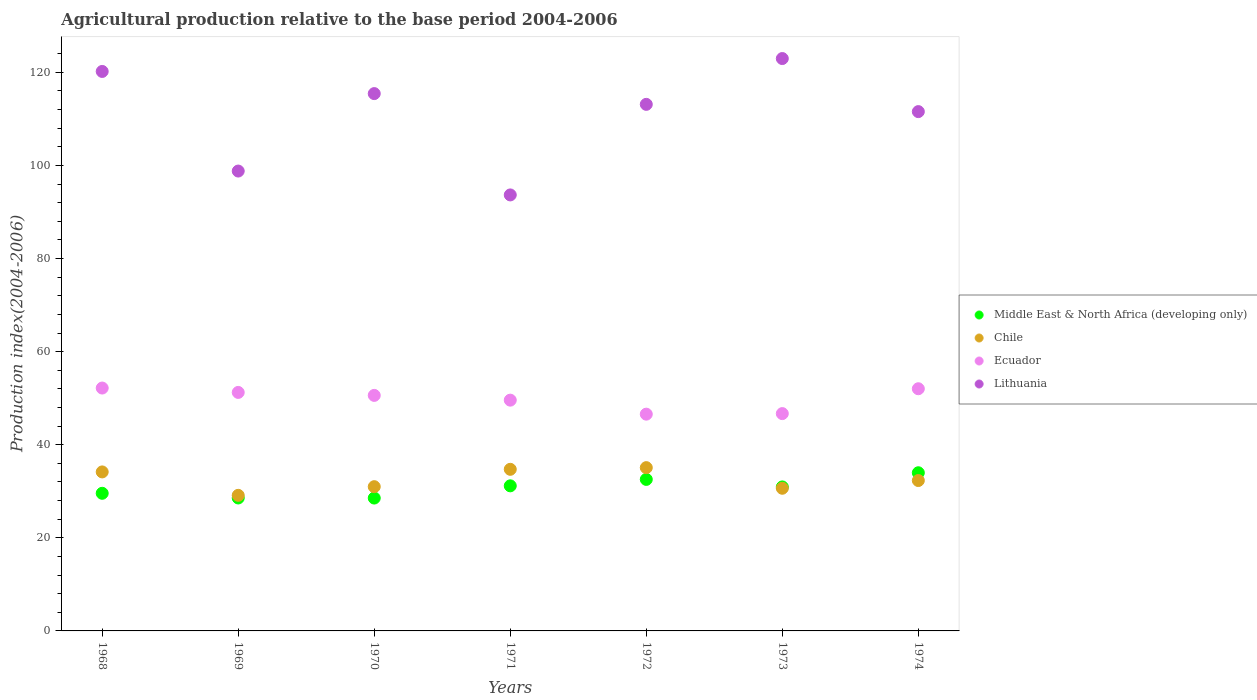Is the number of dotlines equal to the number of legend labels?
Provide a short and direct response. Yes. What is the agricultural production index in Lithuania in 1971?
Make the answer very short. 93.67. Across all years, what is the maximum agricultural production index in Middle East & North Africa (developing only)?
Ensure brevity in your answer.  33.98. Across all years, what is the minimum agricultural production index in Middle East & North Africa (developing only)?
Your answer should be very brief. 28.54. In which year was the agricultural production index in Lithuania maximum?
Make the answer very short. 1973. What is the total agricultural production index in Chile in the graph?
Offer a very short reply. 227.04. What is the difference between the agricultural production index in Lithuania in 1970 and that in 1971?
Give a very brief answer. 21.77. What is the difference between the agricultural production index in Middle East & North Africa (developing only) in 1972 and the agricultural production index in Ecuador in 1970?
Provide a succinct answer. -18.05. What is the average agricultural production index in Middle East & North Africa (developing only) per year?
Your response must be concise. 30.76. In the year 1973, what is the difference between the agricultural production index in Chile and agricultural production index in Middle East & North Africa (developing only)?
Keep it short and to the point. -0.29. In how many years, is the agricultural production index in Ecuador greater than 48?
Make the answer very short. 5. What is the ratio of the agricultural production index in Ecuador in 1972 to that in 1973?
Ensure brevity in your answer.  1. Is the difference between the agricultural production index in Chile in 1968 and 1974 greater than the difference between the agricultural production index in Middle East & North Africa (developing only) in 1968 and 1974?
Offer a terse response. Yes. What is the difference between the highest and the second highest agricultural production index in Chile?
Your response must be concise. 0.36. What is the difference between the highest and the lowest agricultural production index in Ecuador?
Make the answer very short. 5.61. In how many years, is the agricultural production index in Ecuador greater than the average agricultural production index in Ecuador taken over all years?
Make the answer very short. 4. Is the sum of the agricultural production index in Lithuania in 1968 and 1974 greater than the maximum agricultural production index in Chile across all years?
Offer a very short reply. Yes. Is the agricultural production index in Middle East & North Africa (developing only) strictly greater than the agricultural production index in Ecuador over the years?
Keep it short and to the point. No. How many dotlines are there?
Provide a succinct answer. 4. How many years are there in the graph?
Your answer should be very brief. 7. What is the difference between two consecutive major ticks on the Y-axis?
Give a very brief answer. 20. Does the graph contain any zero values?
Give a very brief answer. No. Does the graph contain grids?
Offer a terse response. No. How many legend labels are there?
Provide a short and direct response. 4. What is the title of the graph?
Provide a short and direct response. Agricultural production relative to the base period 2004-2006. What is the label or title of the Y-axis?
Your response must be concise. Production index(2004-2006). What is the Production index(2004-2006) of Middle East & North Africa (developing only) in 1968?
Keep it short and to the point. 29.57. What is the Production index(2004-2006) of Chile in 1968?
Your answer should be compact. 34.16. What is the Production index(2004-2006) of Ecuador in 1968?
Your answer should be compact. 52.18. What is the Production index(2004-2006) of Lithuania in 1968?
Your answer should be compact. 120.2. What is the Production index(2004-2006) in Middle East & North Africa (developing only) in 1969?
Your response must be concise. 28.56. What is the Production index(2004-2006) of Chile in 1969?
Keep it short and to the point. 29.13. What is the Production index(2004-2006) in Ecuador in 1969?
Provide a succinct answer. 51.24. What is the Production index(2004-2006) of Lithuania in 1969?
Provide a short and direct response. 98.8. What is the Production index(2004-2006) of Middle East & North Africa (developing only) in 1970?
Your answer should be compact. 28.54. What is the Production index(2004-2006) of Chile in 1970?
Make the answer very short. 30.99. What is the Production index(2004-2006) in Ecuador in 1970?
Provide a succinct answer. 50.6. What is the Production index(2004-2006) of Lithuania in 1970?
Keep it short and to the point. 115.44. What is the Production index(2004-2006) of Middle East & North Africa (developing only) in 1971?
Make the answer very short. 31.17. What is the Production index(2004-2006) of Chile in 1971?
Ensure brevity in your answer.  34.72. What is the Production index(2004-2006) of Ecuador in 1971?
Keep it short and to the point. 49.58. What is the Production index(2004-2006) in Lithuania in 1971?
Ensure brevity in your answer.  93.67. What is the Production index(2004-2006) of Middle East & North Africa (developing only) in 1972?
Offer a terse response. 32.55. What is the Production index(2004-2006) of Chile in 1972?
Offer a terse response. 35.08. What is the Production index(2004-2006) of Ecuador in 1972?
Provide a succinct answer. 46.57. What is the Production index(2004-2006) in Lithuania in 1972?
Provide a succinct answer. 113.13. What is the Production index(2004-2006) of Middle East & North Africa (developing only) in 1973?
Ensure brevity in your answer.  30.94. What is the Production index(2004-2006) of Chile in 1973?
Offer a terse response. 30.65. What is the Production index(2004-2006) of Ecuador in 1973?
Your answer should be compact. 46.69. What is the Production index(2004-2006) of Lithuania in 1973?
Your answer should be compact. 122.97. What is the Production index(2004-2006) of Middle East & North Africa (developing only) in 1974?
Offer a very short reply. 33.98. What is the Production index(2004-2006) in Chile in 1974?
Offer a very short reply. 32.31. What is the Production index(2004-2006) in Ecuador in 1974?
Make the answer very short. 52.03. What is the Production index(2004-2006) of Lithuania in 1974?
Offer a very short reply. 111.57. Across all years, what is the maximum Production index(2004-2006) of Middle East & North Africa (developing only)?
Your response must be concise. 33.98. Across all years, what is the maximum Production index(2004-2006) of Chile?
Keep it short and to the point. 35.08. Across all years, what is the maximum Production index(2004-2006) of Ecuador?
Your answer should be very brief. 52.18. Across all years, what is the maximum Production index(2004-2006) of Lithuania?
Make the answer very short. 122.97. Across all years, what is the minimum Production index(2004-2006) in Middle East & North Africa (developing only)?
Provide a succinct answer. 28.54. Across all years, what is the minimum Production index(2004-2006) in Chile?
Your answer should be compact. 29.13. Across all years, what is the minimum Production index(2004-2006) of Ecuador?
Your answer should be very brief. 46.57. Across all years, what is the minimum Production index(2004-2006) of Lithuania?
Your answer should be compact. 93.67. What is the total Production index(2004-2006) of Middle East & North Africa (developing only) in the graph?
Your answer should be very brief. 215.31. What is the total Production index(2004-2006) in Chile in the graph?
Your answer should be compact. 227.04. What is the total Production index(2004-2006) in Ecuador in the graph?
Offer a very short reply. 348.89. What is the total Production index(2004-2006) of Lithuania in the graph?
Provide a short and direct response. 775.78. What is the difference between the Production index(2004-2006) of Middle East & North Africa (developing only) in 1968 and that in 1969?
Offer a very short reply. 1.01. What is the difference between the Production index(2004-2006) in Chile in 1968 and that in 1969?
Provide a short and direct response. 5.03. What is the difference between the Production index(2004-2006) of Lithuania in 1968 and that in 1969?
Your answer should be compact. 21.4. What is the difference between the Production index(2004-2006) of Middle East & North Africa (developing only) in 1968 and that in 1970?
Ensure brevity in your answer.  1.02. What is the difference between the Production index(2004-2006) in Chile in 1968 and that in 1970?
Keep it short and to the point. 3.17. What is the difference between the Production index(2004-2006) of Ecuador in 1968 and that in 1970?
Provide a short and direct response. 1.58. What is the difference between the Production index(2004-2006) in Lithuania in 1968 and that in 1970?
Your answer should be very brief. 4.76. What is the difference between the Production index(2004-2006) of Middle East & North Africa (developing only) in 1968 and that in 1971?
Give a very brief answer. -1.6. What is the difference between the Production index(2004-2006) of Chile in 1968 and that in 1971?
Provide a short and direct response. -0.56. What is the difference between the Production index(2004-2006) of Ecuador in 1968 and that in 1971?
Ensure brevity in your answer.  2.6. What is the difference between the Production index(2004-2006) in Lithuania in 1968 and that in 1971?
Ensure brevity in your answer.  26.53. What is the difference between the Production index(2004-2006) in Middle East & North Africa (developing only) in 1968 and that in 1972?
Offer a terse response. -2.98. What is the difference between the Production index(2004-2006) of Chile in 1968 and that in 1972?
Your answer should be compact. -0.92. What is the difference between the Production index(2004-2006) of Ecuador in 1968 and that in 1972?
Make the answer very short. 5.61. What is the difference between the Production index(2004-2006) of Lithuania in 1968 and that in 1972?
Offer a terse response. 7.07. What is the difference between the Production index(2004-2006) in Middle East & North Africa (developing only) in 1968 and that in 1973?
Your response must be concise. -1.37. What is the difference between the Production index(2004-2006) in Chile in 1968 and that in 1973?
Ensure brevity in your answer.  3.51. What is the difference between the Production index(2004-2006) of Ecuador in 1968 and that in 1973?
Make the answer very short. 5.49. What is the difference between the Production index(2004-2006) of Lithuania in 1968 and that in 1973?
Offer a very short reply. -2.77. What is the difference between the Production index(2004-2006) in Middle East & North Africa (developing only) in 1968 and that in 1974?
Ensure brevity in your answer.  -4.41. What is the difference between the Production index(2004-2006) in Chile in 1968 and that in 1974?
Offer a very short reply. 1.85. What is the difference between the Production index(2004-2006) of Ecuador in 1968 and that in 1974?
Your answer should be compact. 0.15. What is the difference between the Production index(2004-2006) of Lithuania in 1968 and that in 1974?
Offer a very short reply. 8.63. What is the difference between the Production index(2004-2006) of Middle East & North Africa (developing only) in 1969 and that in 1970?
Keep it short and to the point. 0.02. What is the difference between the Production index(2004-2006) in Chile in 1969 and that in 1970?
Offer a very short reply. -1.86. What is the difference between the Production index(2004-2006) in Ecuador in 1969 and that in 1970?
Make the answer very short. 0.64. What is the difference between the Production index(2004-2006) in Lithuania in 1969 and that in 1970?
Your answer should be compact. -16.64. What is the difference between the Production index(2004-2006) of Middle East & North Africa (developing only) in 1969 and that in 1971?
Your answer should be compact. -2.61. What is the difference between the Production index(2004-2006) of Chile in 1969 and that in 1971?
Your response must be concise. -5.59. What is the difference between the Production index(2004-2006) in Ecuador in 1969 and that in 1971?
Your answer should be compact. 1.66. What is the difference between the Production index(2004-2006) in Lithuania in 1969 and that in 1971?
Offer a terse response. 5.13. What is the difference between the Production index(2004-2006) of Middle East & North Africa (developing only) in 1969 and that in 1972?
Ensure brevity in your answer.  -3.99. What is the difference between the Production index(2004-2006) in Chile in 1969 and that in 1972?
Give a very brief answer. -5.95. What is the difference between the Production index(2004-2006) in Ecuador in 1969 and that in 1972?
Your answer should be compact. 4.67. What is the difference between the Production index(2004-2006) in Lithuania in 1969 and that in 1972?
Provide a short and direct response. -14.33. What is the difference between the Production index(2004-2006) in Middle East & North Africa (developing only) in 1969 and that in 1973?
Offer a terse response. -2.38. What is the difference between the Production index(2004-2006) of Chile in 1969 and that in 1973?
Offer a very short reply. -1.52. What is the difference between the Production index(2004-2006) of Ecuador in 1969 and that in 1973?
Your response must be concise. 4.55. What is the difference between the Production index(2004-2006) in Lithuania in 1969 and that in 1973?
Keep it short and to the point. -24.17. What is the difference between the Production index(2004-2006) in Middle East & North Africa (developing only) in 1969 and that in 1974?
Provide a short and direct response. -5.42. What is the difference between the Production index(2004-2006) of Chile in 1969 and that in 1974?
Make the answer very short. -3.18. What is the difference between the Production index(2004-2006) in Ecuador in 1969 and that in 1974?
Your answer should be very brief. -0.79. What is the difference between the Production index(2004-2006) of Lithuania in 1969 and that in 1974?
Your answer should be very brief. -12.77. What is the difference between the Production index(2004-2006) in Middle East & North Africa (developing only) in 1970 and that in 1971?
Give a very brief answer. -2.63. What is the difference between the Production index(2004-2006) in Chile in 1970 and that in 1971?
Ensure brevity in your answer.  -3.73. What is the difference between the Production index(2004-2006) in Lithuania in 1970 and that in 1971?
Provide a succinct answer. 21.77. What is the difference between the Production index(2004-2006) of Middle East & North Africa (developing only) in 1970 and that in 1972?
Offer a terse response. -4.01. What is the difference between the Production index(2004-2006) of Chile in 1970 and that in 1972?
Your response must be concise. -4.09. What is the difference between the Production index(2004-2006) of Ecuador in 1970 and that in 1972?
Keep it short and to the point. 4.03. What is the difference between the Production index(2004-2006) of Lithuania in 1970 and that in 1972?
Your response must be concise. 2.31. What is the difference between the Production index(2004-2006) in Middle East & North Africa (developing only) in 1970 and that in 1973?
Ensure brevity in your answer.  -2.39. What is the difference between the Production index(2004-2006) in Chile in 1970 and that in 1973?
Provide a short and direct response. 0.34. What is the difference between the Production index(2004-2006) in Ecuador in 1970 and that in 1973?
Offer a terse response. 3.91. What is the difference between the Production index(2004-2006) of Lithuania in 1970 and that in 1973?
Offer a terse response. -7.53. What is the difference between the Production index(2004-2006) of Middle East & North Africa (developing only) in 1970 and that in 1974?
Keep it short and to the point. -5.44. What is the difference between the Production index(2004-2006) of Chile in 1970 and that in 1974?
Offer a very short reply. -1.32. What is the difference between the Production index(2004-2006) in Ecuador in 1970 and that in 1974?
Offer a terse response. -1.43. What is the difference between the Production index(2004-2006) in Lithuania in 1970 and that in 1974?
Keep it short and to the point. 3.87. What is the difference between the Production index(2004-2006) in Middle East & North Africa (developing only) in 1971 and that in 1972?
Provide a short and direct response. -1.38. What is the difference between the Production index(2004-2006) of Chile in 1971 and that in 1972?
Ensure brevity in your answer.  -0.36. What is the difference between the Production index(2004-2006) in Ecuador in 1971 and that in 1972?
Your response must be concise. 3.01. What is the difference between the Production index(2004-2006) of Lithuania in 1971 and that in 1972?
Provide a succinct answer. -19.46. What is the difference between the Production index(2004-2006) in Middle East & North Africa (developing only) in 1971 and that in 1973?
Your response must be concise. 0.24. What is the difference between the Production index(2004-2006) in Chile in 1971 and that in 1973?
Ensure brevity in your answer.  4.07. What is the difference between the Production index(2004-2006) of Ecuador in 1971 and that in 1973?
Keep it short and to the point. 2.89. What is the difference between the Production index(2004-2006) in Lithuania in 1971 and that in 1973?
Give a very brief answer. -29.3. What is the difference between the Production index(2004-2006) of Middle East & North Africa (developing only) in 1971 and that in 1974?
Keep it short and to the point. -2.81. What is the difference between the Production index(2004-2006) in Chile in 1971 and that in 1974?
Give a very brief answer. 2.41. What is the difference between the Production index(2004-2006) of Ecuador in 1971 and that in 1974?
Ensure brevity in your answer.  -2.45. What is the difference between the Production index(2004-2006) of Lithuania in 1971 and that in 1974?
Give a very brief answer. -17.9. What is the difference between the Production index(2004-2006) in Middle East & North Africa (developing only) in 1972 and that in 1973?
Offer a terse response. 1.62. What is the difference between the Production index(2004-2006) in Chile in 1972 and that in 1973?
Make the answer very short. 4.43. What is the difference between the Production index(2004-2006) of Ecuador in 1972 and that in 1973?
Your answer should be compact. -0.12. What is the difference between the Production index(2004-2006) of Lithuania in 1972 and that in 1973?
Give a very brief answer. -9.84. What is the difference between the Production index(2004-2006) of Middle East & North Africa (developing only) in 1972 and that in 1974?
Your answer should be very brief. -1.43. What is the difference between the Production index(2004-2006) of Chile in 1972 and that in 1974?
Your answer should be very brief. 2.77. What is the difference between the Production index(2004-2006) in Ecuador in 1972 and that in 1974?
Provide a succinct answer. -5.46. What is the difference between the Production index(2004-2006) in Lithuania in 1972 and that in 1974?
Make the answer very short. 1.56. What is the difference between the Production index(2004-2006) in Middle East & North Africa (developing only) in 1973 and that in 1974?
Provide a short and direct response. -3.04. What is the difference between the Production index(2004-2006) of Chile in 1973 and that in 1974?
Offer a terse response. -1.66. What is the difference between the Production index(2004-2006) of Ecuador in 1973 and that in 1974?
Give a very brief answer. -5.34. What is the difference between the Production index(2004-2006) in Lithuania in 1973 and that in 1974?
Ensure brevity in your answer.  11.4. What is the difference between the Production index(2004-2006) in Middle East & North Africa (developing only) in 1968 and the Production index(2004-2006) in Chile in 1969?
Your answer should be very brief. 0.44. What is the difference between the Production index(2004-2006) in Middle East & North Africa (developing only) in 1968 and the Production index(2004-2006) in Ecuador in 1969?
Ensure brevity in your answer.  -21.67. What is the difference between the Production index(2004-2006) of Middle East & North Africa (developing only) in 1968 and the Production index(2004-2006) of Lithuania in 1969?
Ensure brevity in your answer.  -69.23. What is the difference between the Production index(2004-2006) in Chile in 1968 and the Production index(2004-2006) in Ecuador in 1969?
Your answer should be very brief. -17.08. What is the difference between the Production index(2004-2006) in Chile in 1968 and the Production index(2004-2006) in Lithuania in 1969?
Your answer should be compact. -64.64. What is the difference between the Production index(2004-2006) of Ecuador in 1968 and the Production index(2004-2006) of Lithuania in 1969?
Offer a very short reply. -46.62. What is the difference between the Production index(2004-2006) in Middle East & North Africa (developing only) in 1968 and the Production index(2004-2006) in Chile in 1970?
Make the answer very short. -1.42. What is the difference between the Production index(2004-2006) in Middle East & North Africa (developing only) in 1968 and the Production index(2004-2006) in Ecuador in 1970?
Your answer should be very brief. -21.03. What is the difference between the Production index(2004-2006) of Middle East & North Africa (developing only) in 1968 and the Production index(2004-2006) of Lithuania in 1970?
Your answer should be very brief. -85.87. What is the difference between the Production index(2004-2006) of Chile in 1968 and the Production index(2004-2006) of Ecuador in 1970?
Ensure brevity in your answer.  -16.44. What is the difference between the Production index(2004-2006) of Chile in 1968 and the Production index(2004-2006) of Lithuania in 1970?
Provide a short and direct response. -81.28. What is the difference between the Production index(2004-2006) in Ecuador in 1968 and the Production index(2004-2006) in Lithuania in 1970?
Keep it short and to the point. -63.26. What is the difference between the Production index(2004-2006) of Middle East & North Africa (developing only) in 1968 and the Production index(2004-2006) of Chile in 1971?
Ensure brevity in your answer.  -5.15. What is the difference between the Production index(2004-2006) of Middle East & North Africa (developing only) in 1968 and the Production index(2004-2006) of Ecuador in 1971?
Your answer should be compact. -20.01. What is the difference between the Production index(2004-2006) of Middle East & North Africa (developing only) in 1968 and the Production index(2004-2006) of Lithuania in 1971?
Provide a short and direct response. -64.1. What is the difference between the Production index(2004-2006) in Chile in 1968 and the Production index(2004-2006) in Ecuador in 1971?
Provide a succinct answer. -15.42. What is the difference between the Production index(2004-2006) of Chile in 1968 and the Production index(2004-2006) of Lithuania in 1971?
Your answer should be compact. -59.51. What is the difference between the Production index(2004-2006) of Ecuador in 1968 and the Production index(2004-2006) of Lithuania in 1971?
Offer a terse response. -41.49. What is the difference between the Production index(2004-2006) in Middle East & North Africa (developing only) in 1968 and the Production index(2004-2006) in Chile in 1972?
Ensure brevity in your answer.  -5.51. What is the difference between the Production index(2004-2006) in Middle East & North Africa (developing only) in 1968 and the Production index(2004-2006) in Ecuador in 1972?
Keep it short and to the point. -17. What is the difference between the Production index(2004-2006) in Middle East & North Africa (developing only) in 1968 and the Production index(2004-2006) in Lithuania in 1972?
Give a very brief answer. -83.56. What is the difference between the Production index(2004-2006) in Chile in 1968 and the Production index(2004-2006) in Ecuador in 1972?
Offer a very short reply. -12.41. What is the difference between the Production index(2004-2006) of Chile in 1968 and the Production index(2004-2006) of Lithuania in 1972?
Ensure brevity in your answer.  -78.97. What is the difference between the Production index(2004-2006) of Ecuador in 1968 and the Production index(2004-2006) of Lithuania in 1972?
Offer a very short reply. -60.95. What is the difference between the Production index(2004-2006) in Middle East & North Africa (developing only) in 1968 and the Production index(2004-2006) in Chile in 1973?
Provide a succinct answer. -1.08. What is the difference between the Production index(2004-2006) in Middle East & North Africa (developing only) in 1968 and the Production index(2004-2006) in Ecuador in 1973?
Offer a terse response. -17.12. What is the difference between the Production index(2004-2006) of Middle East & North Africa (developing only) in 1968 and the Production index(2004-2006) of Lithuania in 1973?
Ensure brevity in your answer.  -93.4. What is the difference between the Production index(2004-2006) in Chile in 1968 and the Production index(2004-2006) in Ecuador in 1973?
Provide a short and direct response. -12.53. What is the difference between the Production index(2004-2006) of Chile in 1968 and the Production index(2004-2006) of Lithuania in 1973?
Provide a short and direct response. -88.81. What is the difference between the Production index(2004-2006) in Ecuador in 1968 and the Production index(2004-2006) in Lithuania in 1973?
Your response must be concise. -70.79. What is the difference between the Production index(2004-2006) in Middle East & North Africa (developing only) in 1968 and the Production index(2004-2006) in Chile in 1974?
Provide a succinct answer. -2.74. What is the difference between the Production index(2004-2006) of Middle East & North Africa (developing only) in 1968 and the Production index(2004-2006) of Ecuador in 1974?
Ensure brevity in your answer.  -22.46. What is the difference between the Production index(2004-2006) in Middle East & North Africa (developing only) in 1968 and the Production index(2004-2006) in Lithuania in 1974?
Keep it short and to the point. -82. What is the difference between the Production index(2004-2006) of Chile in 1968 and the Production index(2004-2006) of Ecuador in 1974?
Keep it short and to the point. -17.87. What is the difference between the Production index(2004-2006) in Chile in 1968 and the Production index(2004-2006) in Lithuania in 1974?
Your answer should be compact. -77.41. What is the difference between the Production index(2004-2006) of Ecuador in 1968 and the Production index(2004-2006) of Lithuania in 1974?
Make the answer very short. -59.39. What is the difference between the Production index(2004-2006) in Middle East & North Africa (developing only) in 1969 and the Production index(2004-2006) in Chile in 1970?
Your answer should be very brief. -2.43. What is the difference between the Production index(2004-2006) of Middle East & North Africa (developing only) in 1969 and the Production index(2004-2006) of Ecuador in 1970?
Provide a short and direct response. -22.04. What is the difference between the Production index(2004-2006) in Middle East & North Africa (developing only) in 1969 and the Production index(2004-2006) in Lithuania in 1970?
Your answer should be very brief. -86.88. What is the difference between the Production index(2004-2006) in Chile in 1969 and the Production index(2004-2006) in Ecuador in 1970?
Your answer should be compact. -21.47. What is the difference between the Production index(2004-2006) in Chile in 1969 and the Production index(2004-2006) in Lithuania in 1970?
Your answer should be very brief. -86.31. What is the difference between the Production index(2004-2006) of Ecuador in 1969 and the Production index(2004-2006) of Lithuania in 1970?
Your response must be concise. -64.2. What is the difference between the Production index(2004-2006) of Middle East & North Africa (developing only) in 1969 and the Production index(2004-2006) of Chile in 1971?
Give a very brief answer. -6.16. What is the difference between the Production index(2004-2006) in Middle East & North Africa (developing only) in 1969 and the Production index(2004-2006) in Ecuador in 1971?
Offer a terse response. -21.02. What is the difference between the Production index(2004-2006) of Middle East & North Africa (developing only) in 1969 and the Production index(2004-2006) of Lithuania in 1971?
Your answer should be very brief. -65.11. What is the difference between the Production index(2004-2006) in Chile in 1969 and the Production index(2004-2006) in Ecuador in 1971?
Your response must be concise. -20.45. What is the difference between the Production index(2004-2006) in Chile in 1969 and the Production index(2004-2006) in Lithuania in 1971?
Provide a short and direct response. -64.54. What is the difference between the Production index(2004-2006) of Ecuador in 1969 and the Production index(2004-2006) of Lithuania in 1971?
Give a very brief answer. -42.43. What is the difference between the Production index(2004-2006) in Middle East & North Africa (developing only) in 1969 and the Production index(2004-2006) in Chile in 1972?
Your answer should be very brief. -6.52. What is the difference between the Production index(2004-2006) in Middle East & North Africa (developing only) in 1969 and the Production index(2004-2006) in Ecuador in 1972?
Provide a short and direct response. -18.01. What is the difference between the Production index(2004-2006) in Middle East & North Africa (developing only) in 1969 and the Production index(2004-2006) in Lithuania in 1972?
Give a very brief answer. -84.57. What is the difference between the Production index(2004-2006) in Chile in 1969 and the Production index(2004-2006) in Ecuador in 1972?
Your response must be concise. -17.44. What is the difference between the Production index(2004-2006) in Chile in 1969 and the Production index(2004-2006) in Lithuania in 1972?
Provide a succinct answer. -84. What is the difference between the Production index(2004-2006) in Ecuador in 1969 and the Production index(2004-2006) in Lithuania in 1972?
Provide a short and direct response. -61.89. What is the difference between the Production index(2004-2006) in Middle East & North Africa (developing only) in 1969 and the Production index(2004-2006) in Chile in 1973?
Your answer should be very brief. -2.09. What is the difference between the Production index(2004-2006) in Middle East & North Africa (developing only) in 1969 and the Production index(2004-2006) in Ecuador in 1973?
Your answer should be compact. -18.13. What is the difference between the Production index(2004-2006) of Middle East & North Africa (developing only) in 1969 and the Production index(2004-2006) of Lithuania in 1973?
Ensure brevity in your answer.  -94.41. What is the difference between the Production index(2004-2006) of Chile in 1969 and the Production index(2004-2006) of Ecuador in 1973?
Provide a short and direct response. -17.56. What is the difference between the Production index(2004-2006) in Chile in 1969 and the Production index(2004-2006) in Lithuania in 1973?
Give a very brief answer. -93.84. What is the difference between the Production index(2004-2006) in Ecuador in 1969 and the Production index(2004-2006) in Lithuania in 1973?
Make the answer very short. -71.73. What is the difference between the Production index(2004-2006) in Middle East & North Africa (developing only) in 1969 and the Production index(2004-2006) in Chile in 1974?
Provide a succinct answer. -3.75. What is the difference between the Production index(2004-2006) of Middle East & North Africa (developing only) in 1969 and the Production index(2004-2006) of Ecuador in 1974?
Your answer should be compact. -23.47. What is the difference between the Production index(2004-2006) of Middle East & North Africa (developing only) in 1969 and the Production index(2004-2006) of Lithuania in 1974?
Your answer should be compact. -83.01. What is the difference between the Production index(2004-2006) in Chile in 1969 and the Production index(2004-2006) in Ecuador in 1974?
Provide a succinct answer. -22.9. What is the difference between the Production index(2004-2006) of Chile in 1969 and the Production index(2004-2006) of Lithuania in 1974?
Offer a terse response. -82.44. What is the difference between the Production index(2004-2006) in Ecuador in 1969 and the Production index(2004-2006) in Lithuania in 1974?
Your answer should be very brief. -60.33. What is the difference between the Production index(2004-2006) of Middle East & North Africa (developing only) in 1970 and the Production index(2004-2006) of Chile in 1971?
Make the answer very short. -6.18. What is the difference between the Production index(2004-2006) in Middle East & North Africa (developing only) in 1970 and the Production index(2004-2006) in Ecuador in 1971?
Your answer should be compact. -21.04. What is the difference between the Production index(2004-2006) of Middle East & North Africa (developing only) in 1970 and the Production index(2004-2006) of Lithuania in 1971?
Your response must be concise. -65.13. What is the difference between the Production index(2004-2006) of Chile in 1970 and the Production index(2004-2006) of Ecuador in 1971?
Ensure brevity in your answer.  -18.59. What is the difference between the Production index(2004-2006) of Chile in 1970 and the Production index(2004-2006) of Lithuania in 1971?
Keep it short and to the point. -62.68. What is the difference between the Production index(2004-2006) of Ecuador in 1970 and the Production index(2004-2006) of Lithuania in 1971?
Your answer should be very brief. -43.07. What is the difference between the Production index(2004-2006) in Middle East & North Africa (developing only) in 1970 and the Production index(2004-2006) in Chile in 1972?
Give a very brief answer. -6.54. What is the difference between the Production index(2004-2006) in Middle East & North Africa (developing only) in 1970 and the Production index(2004-2006) in Ecuador in 1972?
Provide a short and direct response. -18.03. What is the difference between the Production index(2004-2006) of Middle East & North Africa (developing only) in 1970 and the Production index(2004-2006) of Lithuania in 1972?
Your answer should be compact. -84.59. What is the difference between the Production index(2004-2006) in Chile in 1970 and the Production index(2004-2006) in Ecuador in 1972?
Your response must be concise. -15.58. What is the difference between the Production index(2004-2006) of Chile in 1970 and the Production index(2004-2006) of Lithuania in 1972?
Provide a succinct answer. -82.14. What is the difference between the Production index(2004-2006) of Ecuador in 1970 and the Production index(2004-2006) of Lithuania in 1972?
Ensure brevity in your answer.  -62.53. What is the difference between the Production index(2004-2006) of Middle East & North Africa (developing only) in 1970 and the Production index(2004-2006) of Chile in 1973?
Your response must be concise. -2.11. What is the difference between the Production index(2004-2006) of Middle East & North Africa (developing only) in 1970 and the Production index(2004-2006) of Ecuador in 1973?
Give a very brief answer. -18.15. What is the difference between the Production index(2004-2006) in Middle East & North Africa (developing only) in 1970 and the Production index(2004-2006) in Lithuania in 1973?
Ensure brevity in your answer.  -94.43. What is the difference between the Production index(2004-2006) of Chile in 1970 and the Production index(2004-2006) of Ecuador in 1973?
Offer a very short reply. -15.7. What is the difference between the Production index(2004-2006) in Chile in 1970 and the Production index(2004-2006) in Lithuania in 1973?
Make the answer very short. -91.98. What is the difference between the Production index(2004-2006) of Ecuador in 1970 and the Production index(2004-2006) of Lithuania in 1973?
Your answer should be compact. -72.37. What is the difference between the Production index(2004-2006) of Middle East & North Africa (developing only) in 1970 and the Production index(2004-2006) of Chile in 1974?
Your answer should be very brief. -3.77. What is the difference between the Production index(2004-2006) in Middle East & North Africa (developing only) in 1970 and the Production index(2004-2006) in Ecuador in 1974?
Provide a short and direct response. -23.49. What is the difference between the Production index(2004-2006) in Middle East & North Africa (developing only) in 1970 and the Production index(2004-2006) in Lithuania in 1974?
Ensure brevity in your answer.  -83.03. What is the difference between the Production index(2004-2006) in Chile in 1970 and the Production index(2004-2006) in Ecuador in 1974?
Offer a terse response. -21.04. What is the difference between the Production index(2004-2006) in Chile in 1970 and the Production index(2004-2006) in Lithuania in 1974?
Your response must be concise. -80.58. What is the difference between the Production index(2004-2006) of Ecuador in 1970 and the Production index(2004-2006) of Lithuania in 1974?
Your answer should be compact. -60.97. What is the difference between the Production index(2004-2006) in Middle East & North Africa (developing only) in 1971 and the Production index(2004-2006) in Chile in 1972?
Give a very brief answer. -3.91. What is the difference between the Production index(2004-2006) of Middle East & North Africa (developing only) in 1971 and the Production index(2004-2006) of Ecuador in 1972?
Your answer should be compact. -15.4. What is the difference between the Production index(2004-2006) in Middle East & North Africa (developing only) in 1971 and the Production index(2004-2006) in Lithuania in 1972?
Give a very brief answer. -81.96. What is the difference between the Production index(2004-2006) of Chile in 1971 and the Production index(2004-2006) of Ecuador in 1972?
Your answer should be very brief. -11.85. What is the difference between the Production index(2004-2006) of Chile in 1971 and the Production index(2004-2006) of Lithuania in 1972?
Make the answer very short. -78.41. What is the difference between the Production index(2004-2006) of Ecuador in 1971 and the Production index(2004-2006) of Lithuania in 1972?
Offer a very short reply. -63.55. What is the difference between the Production index(2004-2006) of Middle East & North Africa (developing only) in 1971 and the Production index(2004-2006) of Chile in 1973?
Provide a short and direct response. 0.52. What is the difference between the Production index(2004-2006) of Middle East & North Africa (developing only) in 1971 and the Production index(2004-2006) of Ecuador in 1973?
Your answer should be compact. -15.52. What is the difference between the Production index(2004-2006) of Middle East & North Africa (developing only) in 1971 and the Production index(2004-2006) of Lithuania in 1973?
Your answer should be compact. -91.8. What is the difference between the Production index(2004-2006) of Chile in 1971 and the Production index(2004-2006) of Ecuador in 1973?
Offer a terse response. -11.97. What is the difference between the Production index(2004-2006) in Chile in 1971 and the Production index(2004-2006) in Lithuania in 1973?
Provide a succinct answer. -88.25. What is the difference between the Production index(2004-2006) in Ecuador in 1971 and the Production index(2004-2006) in Lithuania in 1973?
Keep it short and to the point. -73.39. What is the difference between the Production index(2004-2006) in Middle East & North Africa (developing only) in 1971 and the Production index(2004-2006) in Chile in 1974?
Give a very brief answer. -1.14. What is the difference between the Production index(2004-2006) in Middle East & North Africa (developing only) in 1971 and the Production index(2004-2006) in Ecuador in 1974?
Offer a very short reply. -20.86. What is the difference between the Production index(2004-2006) in Middle East & North Africa (developing only) in 1971 and the Production index(2004-2006) in Lithuania in 1974?
Your response must be concise. -80.4. What is the difference between the Production index(2004-2006) of Chile in 1971 and the Production index(2004-2006) of Ecuador in 1974?
Give a very brief answer. -17.31. What is the difference between the Production index(2004-2006) in Chile in 1971 and the Production index(2004-2006) in Lithuania in 1974?
Your response must be concise. -76.85. What is the difference between the Production index(2004-2006) of Ecuador in 1971 and the Production index(2004-2006) of Lithuania in 1974?
Your answer should be compact. -61.99. What is the difference between the Production index(2004-2006) of Middle East & North Africa (developing only) in 1972 and the Production index(2004-2006) of Chile in 1973?
Offer a very short reply. 1.9. What is the difference between the Production index(2004-2006) of Middle East & North Africa (developing only) in 1972 and the Production index(2004-2006) of Ecuador in 1973?
Your answer should be compact. -14.14. What is the difference between the Production index(2004-2006) in Middle East & North Africa (developing only) in 1972 and the Production index(2004-2006) in Lithuania in 1973?
Your response must be concise. -90.42. What is the difference between the Production index(2004-2006) in Chile in 1972 and the Production index(2004-2006) in Ecuador in 1973?
Provide a succinct answer. -11.61. What is the difference between the Production index(2004-2006) of Chile in 1972 and the Production index(2004-2006) of Lithuania in 1973?
Offer a terse response. -87.89. What is the difference between the Production index(2004-2006) in Ecuador in 1972 and the Production index(2004-2006) in Lithuania in 1973?
Offer a very short reply. -76.4. What is the difference between the Production index(2004-2006) in Middle East & North Africa (developing only) in 1972 and the Production index(2004-2006) in Chile in 1974?
Give a very brief answer. 0.24. What is the difference between the Production index(2004-2006) of Middle East & North Africa (developing only) in 1972 and the Production index(2004-2006) of Ecuador in 1974?
Offer a terse response. -19.48. What is the difference between the Production index(2004-2006) in Middle East & North Africa (developing only) in 1972 and the Production index(2004-2006) in Lithuania in 1974?
Your answer should be compact. -79.02. What is the difference between the Production index(2004-2006) in Chile in 1972 and the Production index(2004-2006) in Ecuador in 1974?
Your answer should be compact. -16.95. What is the difference between the Production index(2004-2006) of Chile in 1972 and the Production index(2004-2006) of Lithuania in 1974?
Offer a terse response. -76.49. What is the difference between the Production index(2004-2006) in Ecuador in 1972 and the Production index(2004-2006) in Lithuania in 1974?
Keep it short and to the point. -65. What is the difference between the Production index(2004-2006) in Middle East & North Africa (developing only) in 1973 and the Production index(2004-2006) in Chile in 1974?
Your answer should be very brief. -1.37. What is the difference between the Production index(2004-2006) in Middle East & North Africa (developing only) in 1973 and the Production index(2004-2006) in Ecuador in 1974?
Your answer should be compact. -21.09. What is the difference between the Production index(2004-2006) of Middle East & North Africa (developing only) in 1973 and the Production index(2004-2006) of Lithuania in 1974?
Provide a succinct answer. -80.63. What is the difference between the Production index(2004-2006) of Chile in 1973 and the Production index(2004-2006) of Ecuador in 1974?
Give a very brief answer. -21.38. What is the difference between the Production index(2004-2006) of Chile in 1973 and the Production index(2004-2006) of Lithuania in 1974?
Ensure brevity in your answer.  -80.92. What is the difference between the Production index(2004-2006) of Ecuador in 1973 and the Production index(2004-2006) of Lithuania in 1974?
Your answer should be very brief. -64.88. What is the average Production index(2004-2006) in Middle East & North Africa (developing only) per year?
Your response must be concise. 30.76. What is the average Production index(2004-2006) of Chile per year?
Make the answer very short. 32.43. What is the average Production index(2004-2006) in Ecuador per year?
Your response must be concise. 49.84. What is the average Production index(2004-2006) of Lithuania per year?
Your answer should be compact. 110.83. In the year 1968, what is the difference between the Production index(2004-2006) in Middle East & North Africa (developing only) and Production index(2004-2006) in Chile?
Offer a very short reply. -4.59. In the year 1968, what is the difference between the Production index(2004-2006) in Middle East & North Africa (developing only) and Production index(2004-2006) in Ecuador?
Your answer should be compact. -22.61. In the year 1968, what is the difference between the Production index(2004-2006) of Middle East & North Africa (developing only) and Production index(2004-2006) of Lithuania?
Provide a short and direct response. -90.63. In the year 1968, what is the difference between the Production index(2004-2006) in Chile and Production index(2004-2006) in Ecuador?
Offer a very short reply. -18.02. In the year 1968, what is the difference between the Production index(2004-2006) in Chile and Production index(2004-2006) in Lithuania?
Your response must be concise. -86.04. In the year 1968, what is the difference between the Production index(2004-2006) in Ecuador and Production index(2004-2006) in Lithuania?
Your answer should be compact. -68.02. In the year 1969, what is the difference between the Production index(2004-2006) in Middle East & North Africa (developing only) and Production index(2004-2006) in Chile?
Your response must be concise. -0.57. In the year 1969, what is the difference between the Production index(2004-2006) of Middle East & North Africa (developing only) and Production index(2004-2006) of Ecuador?
Offer a very short reply. -22.68. In the year 1969, what is the difference between the Production index(2004-2006) in Middle East & North Africa (developing only) and Production index(2004-2006) in Lithuania?
Provide a short and direct response. -70.24. In the year 1969, what is the difference between the Production index(2004-2006) of Chile and Production index(2004-2006) of Ecuador?
Your answer should be compact. -22.11. In the year 1969, what is the difference between the Production index(2004-2006) of Chile and Production index(2004-2006) of Lithuania?
Make the answer very short. -69.67. In the year 1969, what is the difference between the Production index(2004-2006) in Ecuador and Production index(2004-2006) in Lithuania?
Ensure brevity in your answer.  -47.56. In the year 1970, what is the difference between the Production index(2004-2006) of Middle East & North Africa (developing only) and Production index(2004-2006) of Chile?
Ensure brevity in your answer.  -2.45. In the year 1970, what is the difference between the Production index(2004-2006) in Middle East & North Africa (developing only) and Production index(2004-2006) in Ecuador?
Make the answer very short. -22.06. In the year 1970, what is the difference between the Production index(2004-2006) of Middle East & North Africa (developing only) and Production index(2004-2006) of Lithuania?
Your answer should be compact. -86.9. In the year 1970, what is the difference between the Production index(2004-2006) in Chile and Production index(2004-2006) in Ecuador?
Make the answer very short. -19.61. In the year 1970, what is the difference between the Production index(2004-2006) of Chile and Production index(2004-2006) of Lithuania?
Give a very brief answer. -84.45. In the year 1970, what is the difference between the Production index(2004-2006) in Ecuador and Production index(2004-2006) in Lithuania?
Your answer should be compact. -64.84. In the year 1971, what is the difference between the Production index(2004-2006) in Middle East & North Africa (developing only) and Production index(2004-2006) in Chile?
Offer a very short reply. -3.55. In the year 1971, what is the difference between the Production index(2004-2006) of Middle East & North Africa (developing only) and Production index(2004-2006) of Ecuador?
Give a very brief answer. -18.41. In the year 1971, what is the difference between the Production index(2004-2006) in Middle East & North Africa (developing only) and Production index(2004-2006) in Lithuania?
Provide a short and direct response. -62.5. In the year 1971, what is the difference between the Production index(2004-2006) of Chile and Production index(2004-2006) of Ecuador?
Give a very brief answer. -14.86. In the year 1971, what is the difference between the Production index(2004-2006) in Chile and Production index(2004-2006) in Lithuania?
Offer a very short reply. -58.95. In the year 1971, what is the difference between the Production index(2004-2006) in Ecuador and Production index(2004-2006) in Lithuania?
Your answer should be very brief. -44.09. In the year 1972, what is the difference between the Production index(2004-2006) of Middle East & North Africa (developing only) and Production index(2004-2006) of Chile?
Make the answer very short. -2.53. In the year 1972, what is the difference between the Production index(2004-2006) of Middle East & North Africa (developing only) and Production index(2004-2006) of Ecuador?
Provide a short and direct response. -14.02. In the year 1972, what is the difference between the Production index(2004-2006) of Middle East & North Africa (developing only) and Production index(2004-2006) of Lithuania?
Offer a terse response. -80.58. In the year 1972, what is the difference between the Production index(2004-2006) in Chile and Production index(2004-2006) in Ecuador?
Offer a very short reply. -11.49. In the year 1972, what is the difference between the Production index(2004-2006) of Chile and Production index(2004-2006) of Lithuania?
Your answer should be compact. -78.05. In the year 1972, what is the difference between the Production index(2004-2006) of Ecuador and Production index(2004-2006) of Lithuania?
Provide a succinct answer. -66.56. In the year 1973, what is the difference between the Production index(2004-2006) of Middle East & North Africa (developing only) and Production index(2004-2006) of Chile?
Your answer should be very brief. 0.29. In the year 1973, what is the difference between the Production index(2004-2006) of Middle East & North Africa (developing only) and Production index(2004-2006) of Ecuador?
Ensure brevity in your answer.  -15.75. In the year 1973, what is the difference between the Production index(2004-2006) in Middle East & North Africa (developing only) and Production index(2004-2006) in Lithuania?
Keep it short and to the point. -92.03. In the year 1973, what is the difference between the Production index(2004-2006) of Chile and Production index(2004-2006) of Ecuador?
Give a very brief answer. -16.04. In the year 1973, what is the difference between the Production index(2004-2006) of Chile and Production index(2004-2006) of Lithuania?
Give a very brief answer. -92.32. In the year 1973, what is the difference between the Production index(2004-2006) in Ecuador and Production index(2004-2006) in Lithuania?
Ensure brevity in your answer.  -76.28. In the year 1974, what is the difference between the Production index(2004-2006) in Middle East & North Africa (developing only) and Production index(2004-2006) in Chile?
Your answer should be very brief. 1.67. In the year 1974, what is the difference between the Production index(2004-2006) of Middle East & North Africa (developing only) and Production index(2004-2006) of Ecuador?
Ensure brevity in your answer.  -18.05. In the year 1974, what is the difference between the Production index(2004-2006) of Middle East & North Africa (developing only) and Production index(2004-2006) of Lithuania?
Make the answer very short. -77.59. In the year 1974, what is the difference between the Production index(2004-2006) in Chile and Production index(2004-2006) in Ecuador?
Your answer should be very brief. -19.72. In the year 1974, what is the difference between the Production index(2004-2006) of Chile and Production index(2004-2006) of Lithuania?
Make the answer very short. -79.26. In the year 1974, what is the difference between the Production index(2004-2006) of Ecuador and Production index(2004-2006) of Lithuania?
Make the answer very short. -59.54. What is the ratio of the Production index(2004-2006) in Middle East & North Africa (developing only) in 1968 to that in 1969?
Provide a succinct answer. 1.04. What is the ratio of the Production index(2004-2006) in Chile in 1968 to that in 1969?
Give a very brief answer. 1.17. What is the ratio of the Production index(2004-2006) in Ecuador in 1968 to that in 1969?
Offer a very short reply. 1.02. What is the ratio of the Production index(2004-2006) in Lithuania in 1968 to that in 1969?
Keep it short and to the point. 1.22. What is the ratio of the Production index(2004-2006) of Middle East & North Africa (developing only) in 1968 to that in 1970?
Make the answer very short. 1.04. What is the ratio of the Production index(2004-2006) of Chile in 1968 to that in 1970?
Keep it short and to the point. 1.1. What is the ratio of the Production index(2004-2006) in Ecuador in 1968 to that in 1970?
Keep it short and to the point. 1.03. What is the ratio of the Production index(2004-2006) of Lithuania in 1968 to that in 1970?
Ensure brevity in your answer.  1.04. What is the ratio of the Production index(2004-2006) in Middle East & North Africa (developing only) in 1968 to that in 1971?
Your response must be concise. 0.95. What is the ratio of the Production index(2004-2006) in Chile in 1968 to that in 1971?
Offer a very short reply. 0.98. What is the ratio of the Production index(2004-2006) of Ecuador in 1968 to that in 1971?
Your answer should be very brief. 1.05. What is the ratio of the Production index(2004-2006) in Lithuania in 1968 to that in 1971?
Ensure brevity in your answer.  1.28. What is the ratio of the Production index(2004-2006) of Middle East & North Africa (developing only) in 1968 to that in 1972?
Your answer should be very brief. 0.91. What is the ratio of the Production index(2004-2006) in Chile in 1968 to that in 1972?
Make the answer very short. 0.97. What is the ratio of the Production index(2004-2006) in Ecuador in 1968 to that in 1972?
Make the answer very short. 1.12. What is the ratio of the Production index(2004-2006) of Middle East & North Africa (developing only) in 1968 to that in 1973?
Your answer should be compact. 0.96. What is the ratio of the Production index(2004-2006) in Chile in 1968 to that in 1973?
Your response must be concise. 1.11. What is the ratio of the Production index(2004-2006) in Ecuador in 1968 to that in 1973?
Give a very brief answer. 1.12. What is the ratio of the Production index(2004-2006) of Lithuania in 1968 to that in 1973?
Give a very brief answer. 0.98. What is the ratio of the Production index(2004-2006) in Middle East & North Africa (developing only) in 1968 to that in 1974?
Give a very brief answer. 0.87. What is the ratio of the Production index(2004-2006) of Chile in 1968 to that in 1974?
Provide a succinct answer. 1.06. What is the ratio of the Production index(2004-2006) in Ecuador in 1968 to that in 1974?
Give a very brief answer. 1. What is the ratio of the Production index(2004-2006) of Lithuania in 1968 to that in 1974?
Your answer should be compact. 1.08. What is the ratio of the Production index(2004-2006) of Chile in 1969 to that in 1970?
Make the answer very short. 0.94. What is the ratio of the Production index(2004-2006) in Ecuador in 1969 to that in 1970?
Your response must be concise. 1.01. What is the ratio of the Production index(2004-2006) of Lithuania in 1969 to that in 1970?
Provide a short and direct response. 0.86. What is the ratio of the Production index(2004-2006) of Middle East & North Africa (developing only) in 1969 to that in 1971?
Keep it short and to the point. 0.92. What is the ratio of the Production index(2004-2006) of Chile in 1969 to that in 1971?
Keep it short and to the point. 0.84. What is the ratio of the Production index(2004-2006) in Ecuador in 1969 to that in 1971?
Give a very brief answer. 1.03. What is the ratio of the Production index(2004-2006) of Lithuania in 1969 to that in 1971?
Provide a short and direct response. 1.05. What is the ratio of the Production index(2004-2006) in Middle East & North Africa (developing only) in 1969 to that in 1972?
Your answer should be compact. 0.88. What is the ratio of the Production index(2004-2006) in Chile in 1969 to that in 1972?
Offer a terse response. 0.83. What is the ratio of the Production index(2004-2006) of Ecuador in 1969 to that in 1972?
Provide a succinct answer. 1.1. What is the ratio of the Production index(2004-2006) in Lithuania in 1969 to that in 1972?
Your answer should be very brief. 0.87. What is the ratio of the Production index(2004-2006) of Middle East & North Africa (developing only) in 1969 to that in 1973?
Provide a succinct answer. 0.92. What is the ratio of the Production index(2004-2006) of Chile in 1969 to that in 1973?
Offer a very short reply. 0.95. What is the ratio of the Production index(2004-2006) in Ecuador in 1969 to that in 1973?
Keep it short and to the point. 1.1. What is the ratio of the Production index(2004-2006) in Lithuania in 1969 to that in 1973?
Provide a succinct answer. 0.8. What is the ratio of the Production index(2004-2006) in Middle East & North Africa (developing only) in 1969 to that in 1974?
Keep it short and to the point. 0.84. What is the ratio of the Production index(2004-2006) in Chile in 1969 to that in 1974?
Your answer should be compact. 0.9. What is the ratio of the Production index(2004-2006) of Lithuania in 1969 to that in 1974?
Make the answer very short. 0.89. What is the ratio of the Production index(2004-2006) in Middle East & North Africa (developing only) in 1970 to that in 1971?
Keep it short and to the point. 0.92. What is the ratio of the Production index(2004-2006) in Chile in 1970 to that in 1971?
Give a very brief answer. 0.89. What is the ratio of the Production index(2004-2006) in Ecuador in 1970 to that in 1971?
Make the answer very short. 1.02. What is the ratio of the Production index(2004-2006) in Lithuania in 1970 to that in 1971?
Provide a succinct answer. 1.23. What is the ratio of the Production index(2004-2006) of Middle East & North Africa (developing only) in 1970 to that in 1972?
Ensure brevity in your answer.  0.88. What is the ratio of the Production index(2004-2006) of Chile in 1970 to that in 1972?
Your answer should be compact. 0.88. What is the ratio of the Production index(2004-2006) in Ecuador in 1970 to that in 1972?
Ensure brevity in your answer.  1.09. What is the ratio of the Production index(2004-2006) in Lithuania in 1970 to that in 1972?
Offer a terse response. 1.02. What is the ratio of the Production index(2004-2006) in Middle East & North Africa (developing only) in 1970 to that in 1973?
Offer a terse response. 0.92. What is the ratio of the Production index(2004-2006) of Chile in 1970 to that in 1973?
Offer a terse response. 1.01. What is the ratio of the Production index(2004-2006) of Ecuador in 1970 to that in 1973?
Provide a short and direct response. 1.08. What is the ratio of the Production index(2004-2006) of Lithuania in 1970 to that in 1973?
Provide a succinct answer. 0.94. What is the ratio of the Production index(2004-2006) in Middle East & North Africa (developing only) in 1970 to that in 1974?
Keep it short and to the point. 0.84. What is the ratio of the Production index(2004-2006) of Chile in 1970 to that in 1974?
Offer a very short reply. 0.96. What is the ratio of the Production index(2004-2006) of Ecuador in 1970 to that in 1974?
Give a very brief answer. 0.97. What is the ratio of the Production index(2004-2006) in Lithuania in 1970 to that in 1974?
Give a very brief answer. 1.03. What is the ratio of the Production index(2004-2006) in Middle East & North Africa (developing only) in 1971 to that in 1972?
Keep it short and to the point. 0.96. What is the ratio of the Production index(2004-2006) in Chile in 1971 to that in 1972?
Provide a short and direct response. 0.99. What is the ratio of the Production index(2004-2006) in Ecuador in 1971 to that in 1972?
Your answer should be very brief. 1.06. What is the ratio of the Production index(2004-2006) of Lithuania in 1971 to that in 1972?
Your response must be concise. 0.83. What is the ratio of the Production index(2004-2006) of Middle East & North Africa (developing only) in 1971 to that in 1973?
Offer a terse response. 1.01. What is the ratio of the Production index(2004-2006) in Chile in 1971 to that in 1973?
Keep it short and to the point. 1.13. What is the ratio of the Production index(2004-2006) of Ecuador in 1971 to that in 1973?
Offer a terse response. 1.06. What is the ratio of the Production index(2004-2006) of Lithuania in 1971 to that in 1973?
Offer a very short reply. 0.76. What is the ratio of the Production index(2004-2006) in Middle East & North Africa (developing only) in 1971 to that in 1974?
Make the answer very short. 0.92. What is the ratio of the Production index(2004-2006) in Chile in 1971 to that in 1974?
Your answer should be very brief. 1.07. What is the ratio of the Production index(2004-2006) of Ecuador in 1971 to that in 1974?
Your response must be concise. 0.95. What is the ratio of the Production index(2004-2006) of Lithuania in 1971 to that in 1974?
Keep it short and to the point. 0.84. What is the ratio of the Production index(2004-2006) of Middle East & North Africa (developing only) in 1972 to that in 1973?
Provide a short and direct response. 1.05. What is the ratio of the Production index(2004-2006) of Chile in 1972 to that in 1973?
Provide a short and direct response. 1.14. What is the ratio of the Production index(2004-2006) in Lithuania in 1972 to that in 1973?
Your answer should be very brief. 0.92. What is the ratio of the Production index(2004-2006) of Middle East & North Africa (developing only) in 1972 to that in 1974?
Your response must be concise. 0.96. What is the ratio of the Production index(2004-2006) of Chile in 1972 to that in 1974?
Give a very brief answer. 1.09. What is the ratio of the Production index(2004-2006) in Ecuador in 1972 to that in 1974?
Ensure brevity in your answer.  0.9. What is the ratio of the Production index(2004-2006) in Middle East & North Africa (developing only) in 1973 to that in 1974?
Ensure brevity in your answer.  0.91. What is the ratio of the Production index(2004-2006) of Chile in 1973 to that in 1974?
Offer a very short reply. 0.95. What is the ratio of the Production index(2004-2006) in Ecuador in 1973 to that in 1974?
Provide a succinct answer. 0.9. What is the ratio of the Production index(2004-2006) of Lithuania in 1973 to that in 1974?
Make the answer very short. 1.1. What is the difference between the highest and the second highest Production index(2004-2006) of Middle East & North Africa (developing only)?
Offer a terse response. 1.43. What is the difference between the highest and the second highest Production index(2004-2006) in Chile?
Offer a very short reply. 0.36. What is the difference between the highest and the second highest Production index(2004-2006) of Lithuania?
Provide a succinct answer. 2.77. What is the difference between the highest and the lowest Production index(2004-2006) in Middle East & North Africa (developing only)?
Keep it short and to the point. 5.44. What is the difference between the highest and the lowest Production index(2004-2006) in Chile?
Give a very brief answer. 5.95. What is the difference between the highest and the lowest Production index(2004-2006) of Ecuador?
Give a very brief answer. 5.61. What is the difference between the highest and the lowest Production index(2004-2006) in Lithuania?
Offer a very short reply. 29.3. 